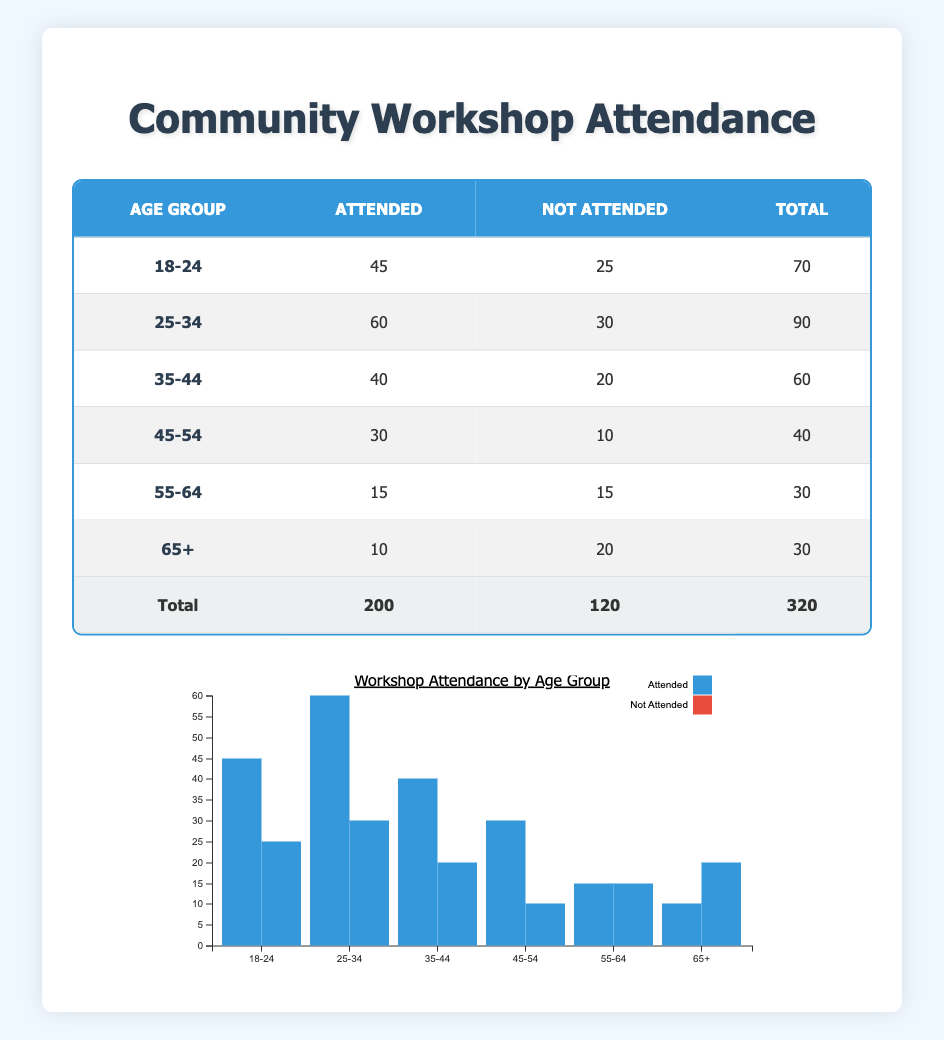What is the total number of residents who attended workshops from the age group 25-34? According to the table, the age group 25-34 has 60 residents marked as "attended." Therefore, the total number of residents who attended workshops from this age group is simply the value in the "Attended" column for this age range.
Answer: 60 How many residents aged 45-54 did not attend the workshops? The value for the "not attended" column for the age group 45-54 is 10. This indicates that 10 residents in this age group did not attend the workshops.
Answer: 10 What is the total number of residents across all age groups who attended the workshops? To get this number, we look at the "Attended" column for each age group and sum the values: 45 + 60 + 40 + 30 + 15 + 10 = 200. Therefore, the total number of residents who attended workshops across all age groups is 200.
Answer: 200 Is it true that more residents aged 55-64 attended workshops than those aged 65 and older? For the age group 55-64, 15 residents attended workshops, and for 65+, only 10 residents attended. Since 15 is greater than 10, the statement is true.
Answer: True What is the average attendance for residents aged 35-44 and 45-54 combined? First, we need the attended values for both groups: 40 for 35-44 and 30 for 45-54. Then, we calculate the sum: 40 + 30 = 70. Next, since there are two groups involved, we divide by 2 for average: 70 / 2 = 35.
Answer: 35 How many more residents aged 18-24 attended workshops compared to those aged 55-64? The number of residents aged 18-24 who attended is 45 and for 55-64, it is 15. To find the difference, we subtract the lower attendance from the higher attendance: 45 - 15 = 30. So, there are 30 more attendees in the 18-24 age group compared to the 55-64 age group.
Answer: 30 What percentage of residents aged 35-44 did not attend the workshops? For the age group 35-44, the number who did not attend is 20. To find the percentage, we use the formula: (not attended / total) * 100. The total for this age group is 40 attended + 20 not attended = 60. Thus, the percentage is (20 / 60) * 100 = 33.33%.
Answer: 33.33% What is the total attendance for all age groups aged 45 or older? The age groups 45-54 have 30 attended and 65+ have 10 attended. Adding these gives us 30 + 10 = 40. Thus, the total attendance for all age groups aged 45 or older is 40 residents.
Answer: 40 Which age group has the highest rate of attendance per total participants? To calculate the rate, we need to find the ratio of attended to total for each group. For the age group 18-24, the ratio is 45/70 = 0.643. For 25-34, it's 60/90 = 0.667. For 35-44, it’s 40/60 = 0.667. For 45-54, it is 30/40 = 0.75. For 55-64, it’s 15/30 = 0.5. For 65+, it’s 10/30 = 0.333. The highest rate is for 45-54 at 0.75.
Answer: 45-54 